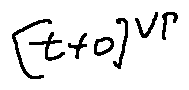<formula> <loc_0><loc_0><loc_500><loc_500>[ t + o ] ^ { v _ { P } }</formula> 